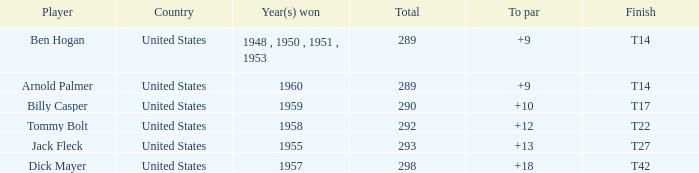In 1960, which country had a total score of less than 290? United States. 